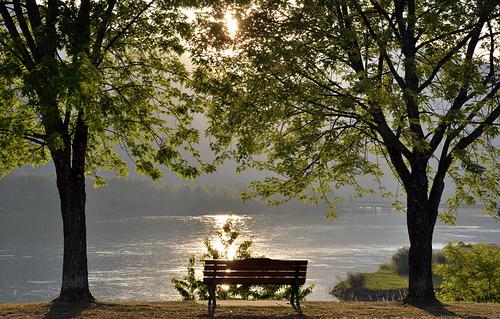What kind of trees are these?
Keep it brief. Oak. Does it look pretty out?
Short answer required. Yes. Are there leaves on the trees?
Concise answer only. Yes. Is this near the water?
Concise answer only. Yes. Could you consider the giraffe to be grazing also?
Keep it brief. No. Is this area well maintained?
Quick response, please. Yes. Is it sunrise or sunset?
Quick response, please. Sunset. How many rungs are on the back of the bench?
Give a very brief answer. 4. Does the bench face the water?
Concise answer only. Yes. What is surrounding the bench?
Quick response, please. Trees. How many trees are in the image?
Give a very brief answer. 2. 